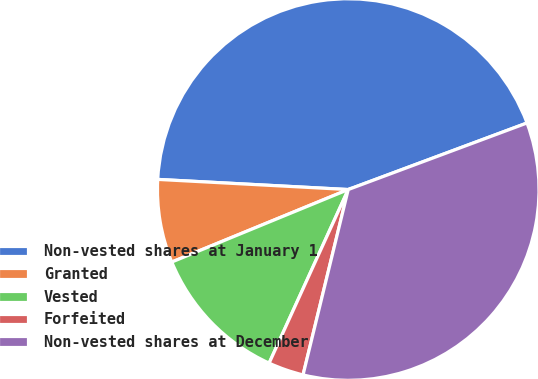Convert chart. <chart><loc_0><loc_0><loc_500><loc_500><pie_chart><fcel>Non-vested shares at January 1<fcel>Granted<fcel>Vested<fcel>Forfeited<fcel>Non-vested shares at December<nl><fcel>43.48%<fcel>7.05%<fcel>11.99%<fcel>3.0%<fcel>34.48%<nl></chart> 